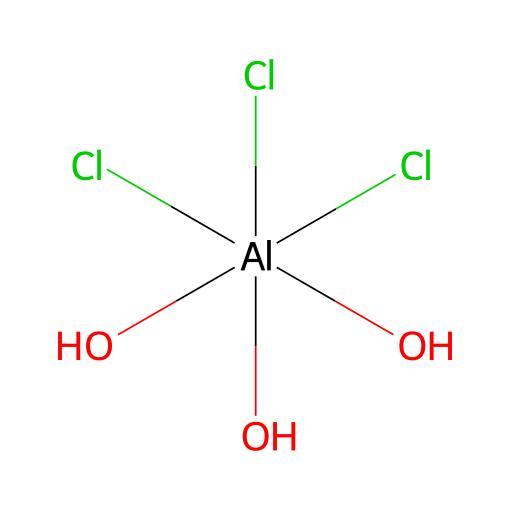How many chlorine atoms are present in this chemical? The SMILES representation shows three chlorine atoms attached to the aluminum atom, as indicated by "(Cl)(Cl)(Cl)".
Answer: three What is the central atom in this molecule? The aluminum (Al) is the central atom in this molecule, as it is connected to multiple other groups including chlorine and hydroxyl groups.
Answer: aluminum How many hydroxyl (OH) groups are there in this chemical? The structure shows three hydroxyl groups represented as "(O)", so there are three hydroxyl groups present in total.
Answer: three What is the oxidation state of aluminum in this compound? In this chemical, aluminum is surrounded by chlorine and oxygen atoms, indicating an oxidation state of +3, which is typical for aluminum in various compounds.
Answer: +3 What type of bond connects aluminum to chlorine? The bonds in this compound are ionic bonds typically formed between metal and non-metals, such as aluminum and chlorine.
Answer: ionic How does the presence of chlorine influence the properties of this chemical? The presence of chlorine contributes to the compound's ability to inhibit perspiration, often increasing solubility and reactivity with sweat.
Answer: inhibits perspiration What role do hydroxyl groups play in this molecular structure? Hydroxyl groups enhance the compound's interaction with water and can influence the overall activity of the antiperspirant effect, adding to its function.
Answer: enhance interaction with water 